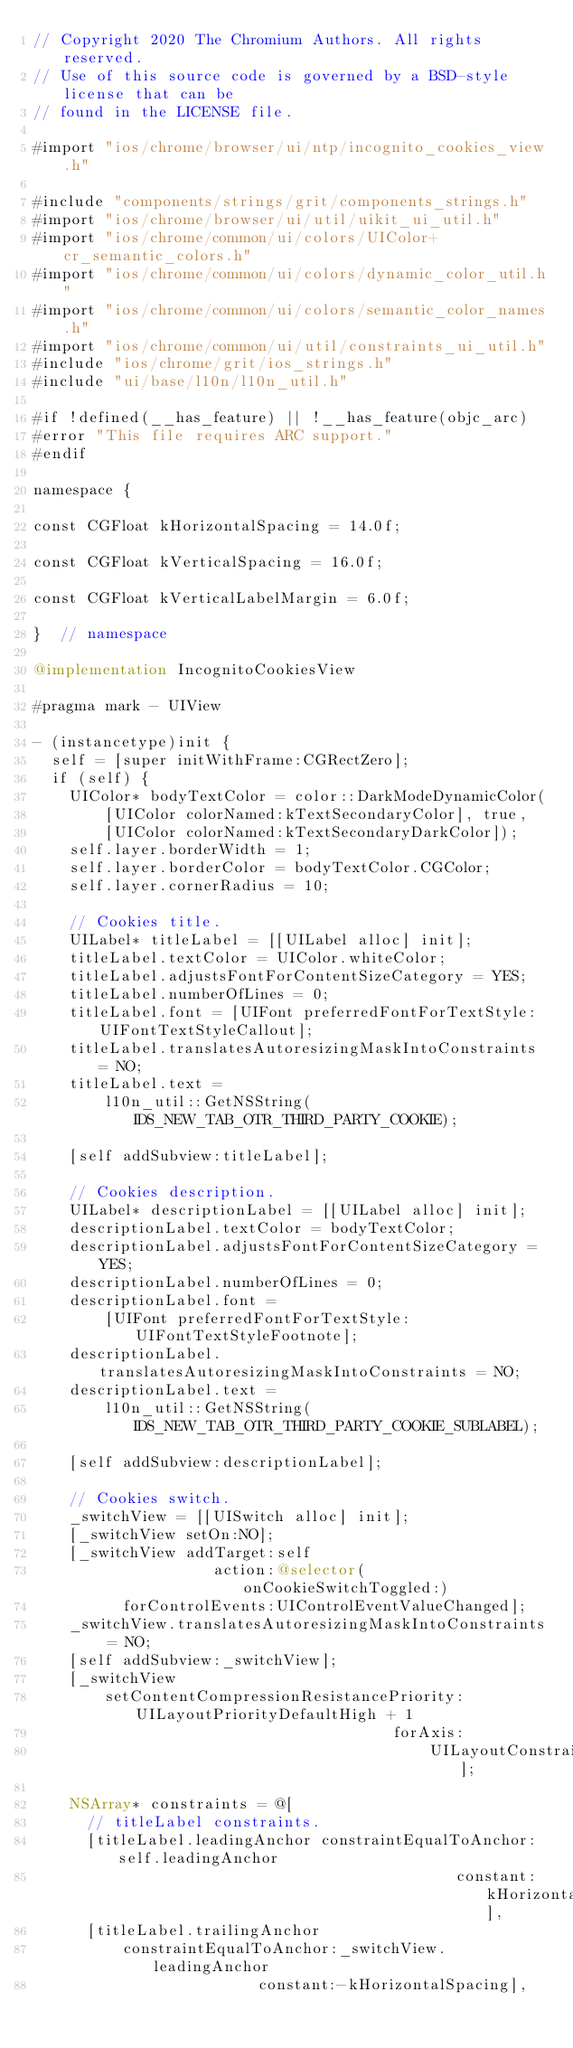Convert code to text. <code><loc_0><loc_0><loc_500><loc_500><_ObjectiveC_>// Copyright 2020 The Chromium Authors. All rights reserved.
// Use of this source code is governed by a BSD-style license that can be
// found in the LICENSE file.

#import "ios/chrome/browser/ui/ntp/incognito_cookies_view.h"

#include "components/strings/grit/components_strings.h"
#import "ios/chrome/browser/ui/util/uikit_ui_util.h"
#import "ios/chrome/common/ui/colors/UIColor+cr_semantic_colors.h"
#import "ios/chrome/common/ui/colors/dynamic_color_util.h"
#import "ios/chrome/common/ui/colors/semantic_color_names.h"
#import "ios/chrome/common/ui/util/constraints_ui_util.h"
#include "ios/chrome/grit/ios_strings.h"
#include "ui/base/l10n/l10n_util.h"

#if !defined(__has_feature) || !__has_feature(objc_arc)
#error "This file requires ARC support."
#endif

namespace {

const CGFloat kHorizontalSpacing = 14.0f;

const CGFloat kVerticalSpacing = 16.0f;

const CGFloat kVerticalLabelMargin = 6.0f;

}  // namespace

@implementation IncognitoCookiesView

#pragma mark - UIView

- (instancetype)init {
  self = [super initWithFrame:CGRectZero];
  if (self) {
    UIColor* bodyTextColor = color::DarkModeDynamicColor(
        [UIColor colorNamed:kTextSecondaryColor], true,
        [UIColor colorNamed:kTextSecondaryDarkColor]);
    self.layer.borderWidth = 1;
    self.layer.borderColor = bodyTextColor.CGColor;
    self.layer.cornerRadius = 10;

    // Cookies title.
    UILabel* titleLabel = [[UILabel alloc] init];
    titleLabel.textColor = UIColor.whiteColor;
    titleLabel.adjustsFontForContentSizeCategory = YES;
    titleLabel.numberOfLines = 0;
    titleLabel.font = [UIFont preferredFontForTextStyle:UIFontTextStyleCallout];
    titleLabel.translatesAutoresizingMaskIntoConstraints = NO;
    titleLabel.text =
        l10n_util::GetNSString(IDS_NEW_TAB_OTR_THIRD_PARTY_COOKIE);

    [self addSubview:titleLabel];

    // Cookies description.
    UILabel* descriptionLabel = [[UILabel alloc] init];
    descriptionLabel.textColor = bodyTextColor;
    descriptionLabel.adjustsFontForContentSizeCategory = YES;
    descriptionLabel.numberOfLines = 0;
    descriptionLabel.font =
        [UIFont preferredFontForTextStyle:UIFontTextStyleFootnote];
    descriptionLabel.translatesAutoresizingMaskIntoConstraints = NO;
    descriptionLabel.text =
        l10n_util::GetNSString(IDS_NEW_TAB_OTR_THIRD_PARTY_COOKIE_SUBLABEL);

    [self addSubview:descriptionLabel];

    // Cookies switch.
    _switchView = [[UISwitch alloc] init];
    [_switchView setOn:NO];
    [_switchView addTarget:self
                    action:@selector(onCookieSwitchToggled:)
          forControlEvents:UIControlEventValueChanged];
    _switchView.translatesAutoresizingMaskIntoConstraints = NO;
    [self addSubview:_switchView];
    [_switchView
        setContentCompressionResistancePriority:UILayoutPriorityDefaultHigh + 1
                                        forAxis:
                                            UILayoutConstraintAxisHorizontal];

    NSArray* constraints = @[
      // titleLabel constraints.
      [titleLabel.leadingAnchor constraintEqualToAnchor:self.leadingAnchor
                                               constant:kHorizontalSpacing],
      [titleLabel.trailingAnchor
          constraintEqualToAnchor:_switchView.leadingAnchor
                         constant:-kHorizontalSpacing],</code> 